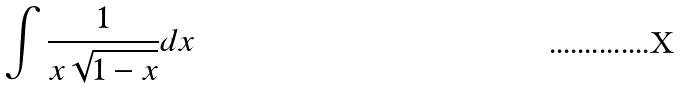<formula> <loc_0><loc_0><loc_500><loc_500>\int \frac { 1 } { x \sqrt { 1 - x } } d x</formula> 